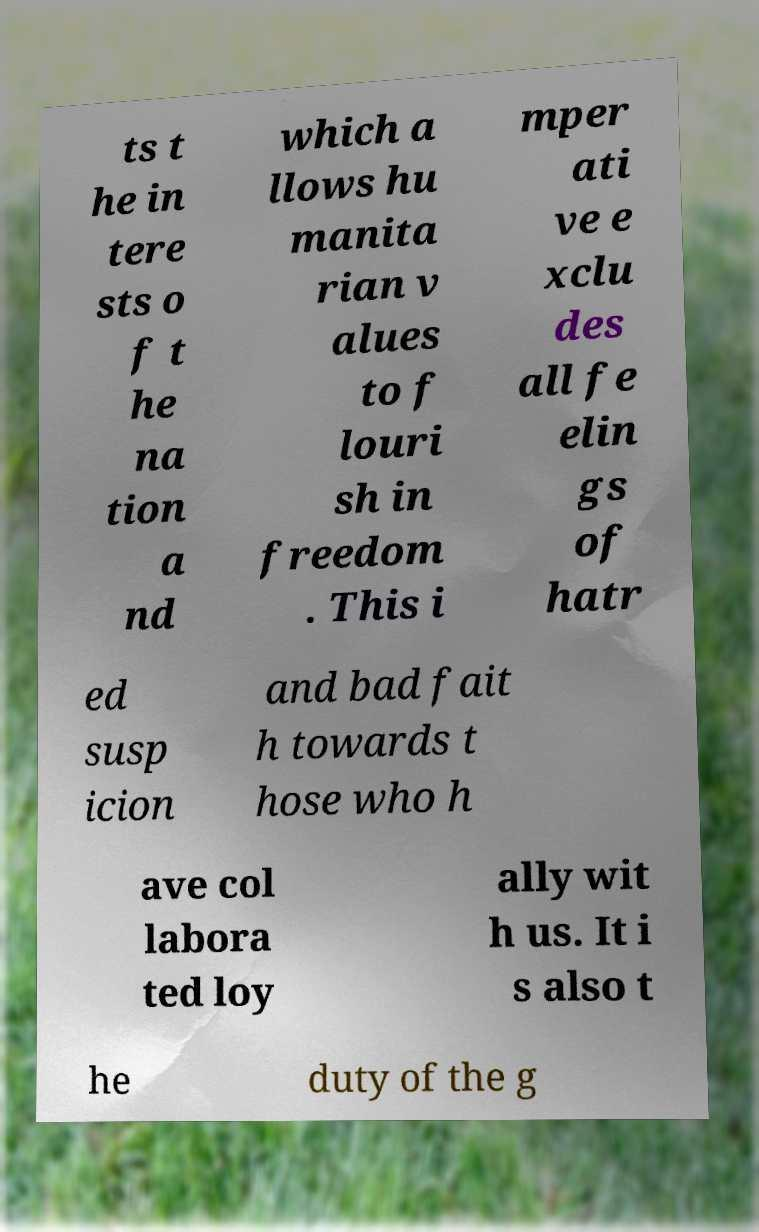Please identify and transcribe the text found in this image. ts t he in tere sts o f t he na tion a nd which a llows hu manita rian v alues to f louri sh in freedom . This i mper ati ve e xclu des all fe elin gs of hatr ed susp icion and bad fait h towards t hose who h ave col labora ted loy ally wit h us. It i s also t he duty of the g 